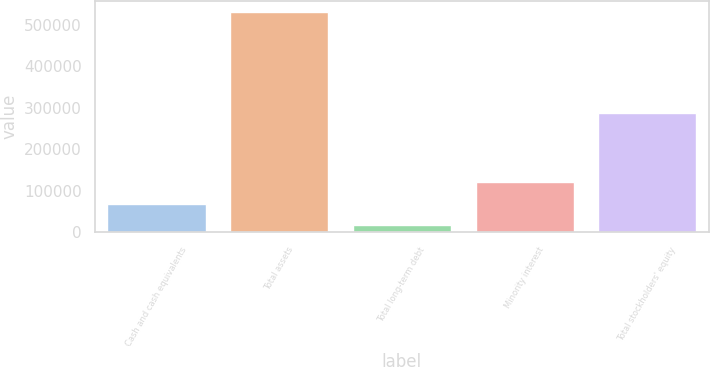<chart> <loc_0><loc_0><loc_500><loc_500><bar_chart><fcel>Cash and cash equivalents<fcel>Total assets<fcel>Total long-term debt<fcel>Minority interest<fcel>Total stockholders' equity<nl><fcel>68480.8<fcel>530647<fcel>17129<fcel>119833<fcel>286487<nl></chart> 